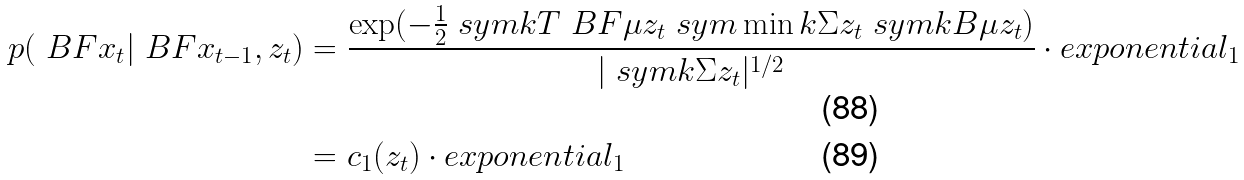Convert formula to latex. <formula><loc_0><loc_0><loc_500><loc_500>p ( \ B F { x } _ { t } | \ B F { x } _ { t - 1 } , z _ { t } ) & = \frac { \exp ( - \frac { 1 } { 2 } \ s y m k T { \ B F { \mu } } { z _ { t } } \ s y m \min k { \Sigma } { z _ { t } } \ s y m k B { \mu } { z _ { t } } ) } { | \ s y m k { \Sigma } { z _ { t } } | ^ { 1 / 2 } } \cdot e x p o n e n t i a l _ { 1 } \\ & = c _ { 1 } ( z _ { t } ) \cdot e x p o n e n t i a l _ { 1 }</formula> 